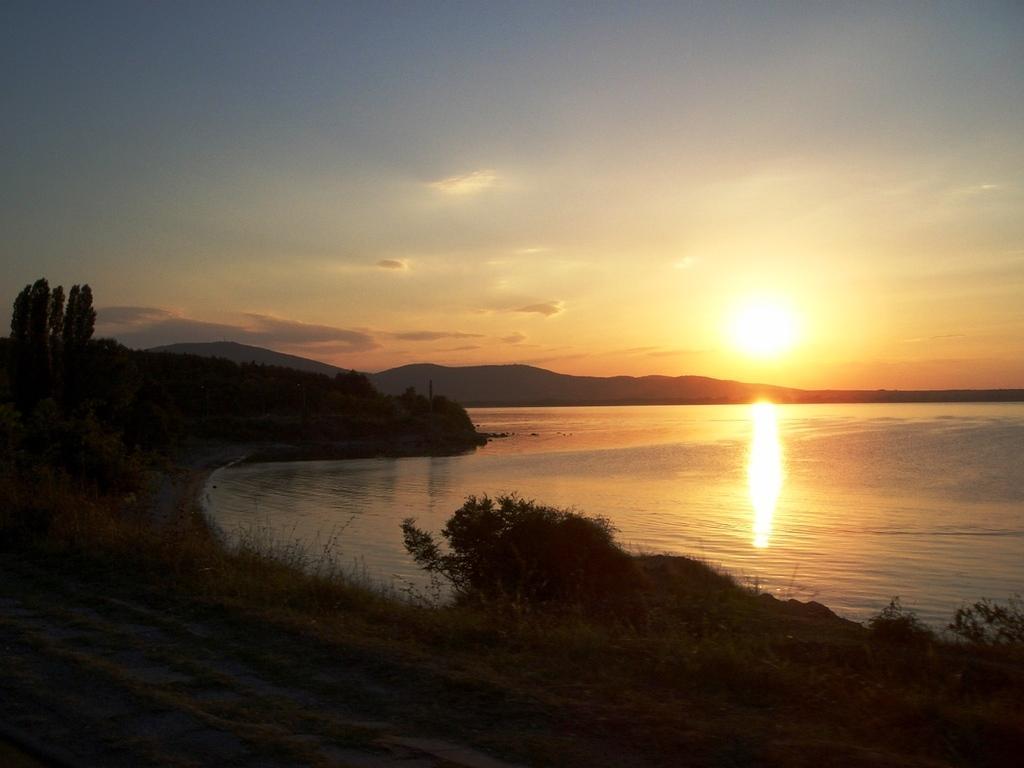How would you summarize this image in a sentence or two? In this image at the bottom there is grass and walkway, and on the right side of the image there is a river. And in the background there are mountains, trees and sun. At the top there is sky. 